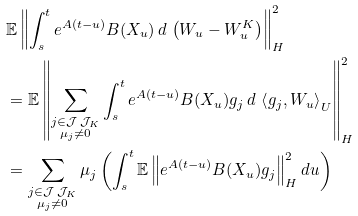Convert formula to latex. <formula><loc_0><loc_0><loc_500><loc_500>& \mathbb { E } \left \| \int _ { s } ^ { t } e ^ { A ( t - u ) } B ( X _ { u } ) \, d \, \left ( W _ { u } - W ^ { K } _ { u } \right ) \right \| _ { H } ^ { 2 } \\ & = \mathbb { E } \left \| \sum _ { \substack { j \in \mathcal { J } \ \mathcal { J } _ { K } \\ \mu _ { j } \neq 0 } } \int _ { s } ^ { t } e ^ { A ( t - u ) } B ( X _ { u } ) g _ { j } \, d \, \left < g _ { j } , W _ { u } \right > _ { U } \right \| _ { H } ^ { 2 } \\ & = \sum _ { \substack { j \in \mathcal { J } \ \mathcal { J } _ { K } \\ \mu _ { j } \neq 0 } } \mu _ { j } \left ( \int _ { s } ^ { t } \mathbb { E } \left \| e ^ { A ( t - u ) } B ( X _ { u } ) g _ { j } \right \| _ { H } ^ { 2 } d u \right )</formula> 